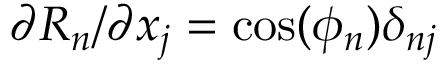Convert formula to latex. <formula><loc_0><loc_0><loc_500><loc_500>{ \partial R _ { n } } / { \partial x _ { j } } = \cos ( \phi _ { n } ) \delta _ { n j }</formula> 